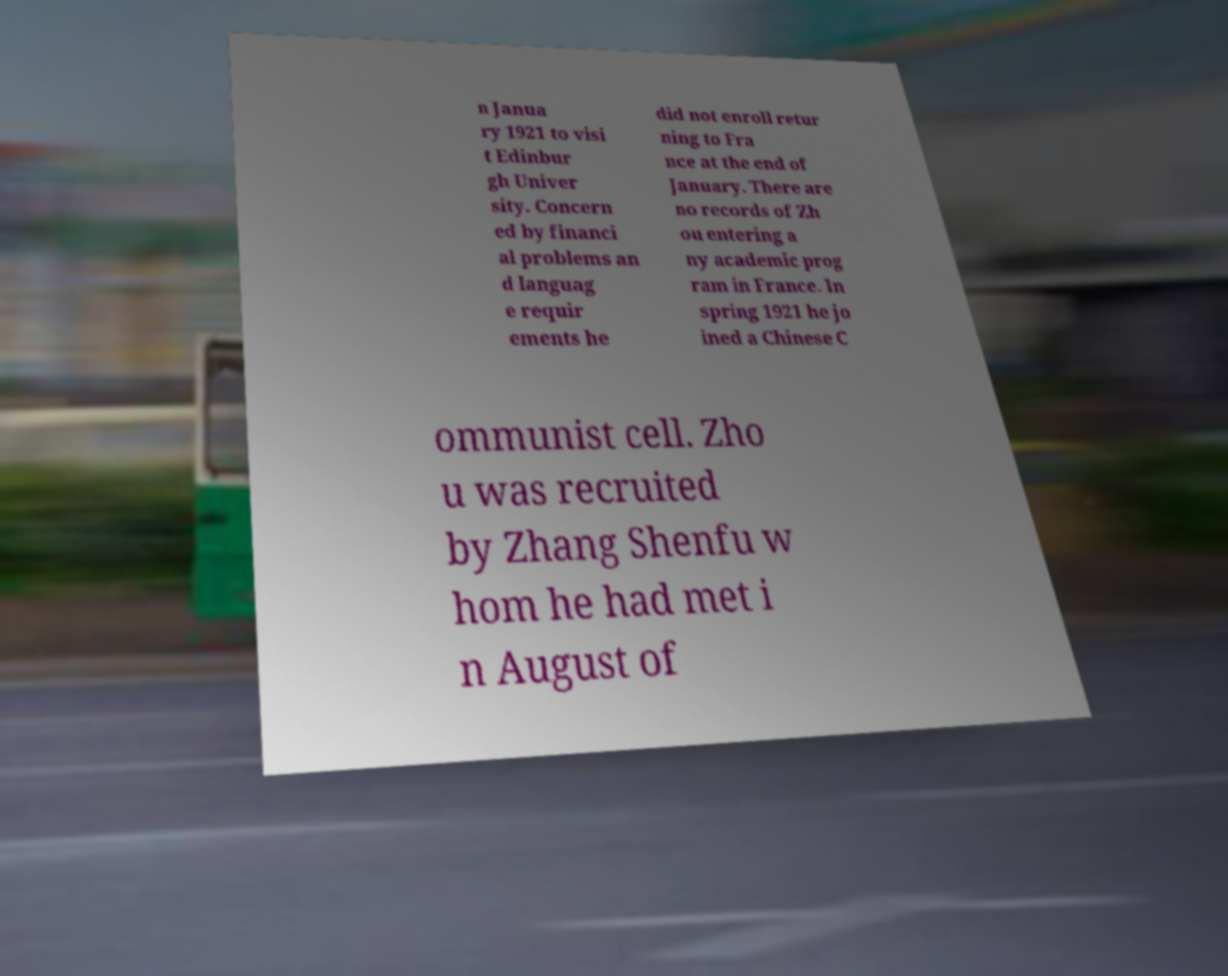Can you accurately transcribe the text from the provided image for me? n Janua ry 1921 to visi t Edinbur gh Univer sity. Concern ed by financi al problems an d languag e requir ements he did not enroll retur ning to Fra nce at the end of January. There are no records of Zh ou entering a ny academic prog ram in France. In spring 1921 he jo ined a Chinese C ommunist cell. Zho u was recruited by Zhang Shenfu w hom he had met i n August of 